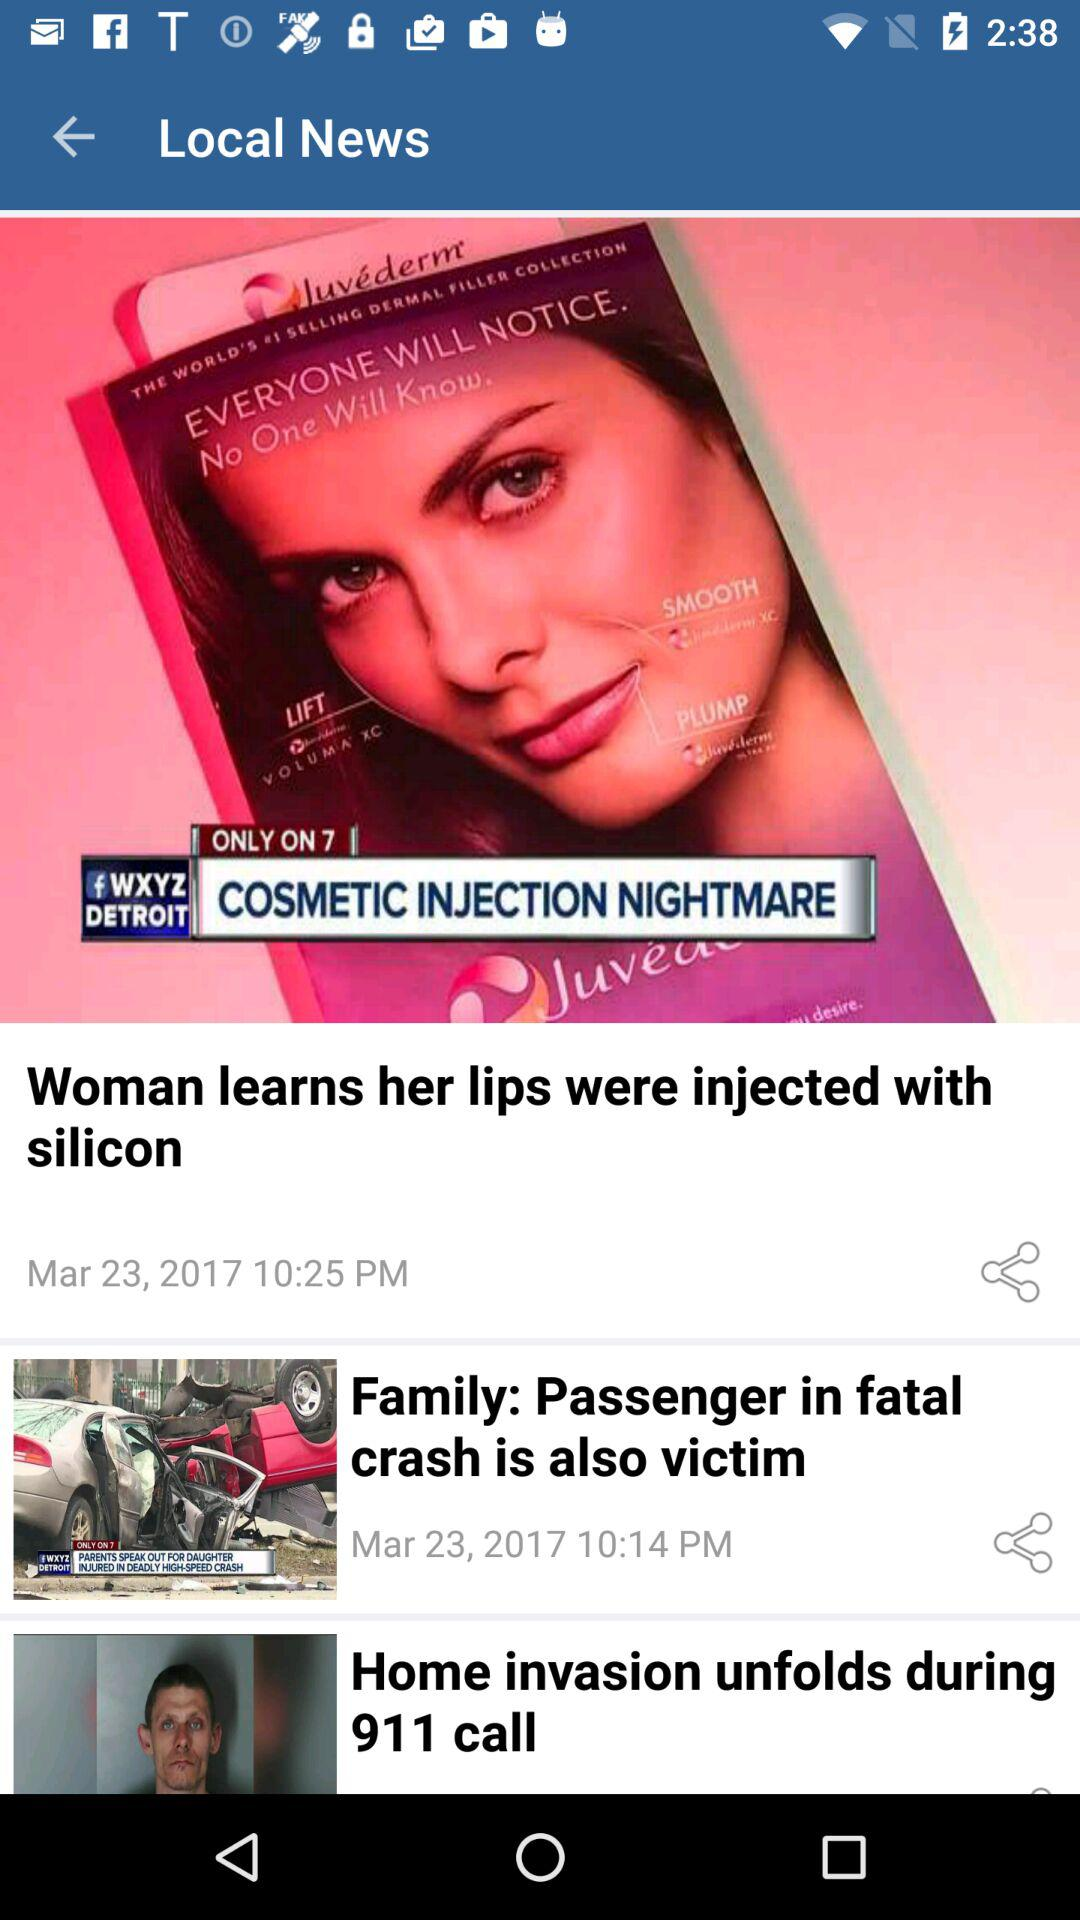What is the date when the news "Family: Passenger in fatal crash is also victim" was posted? The news was posted on March 23, 2017. 